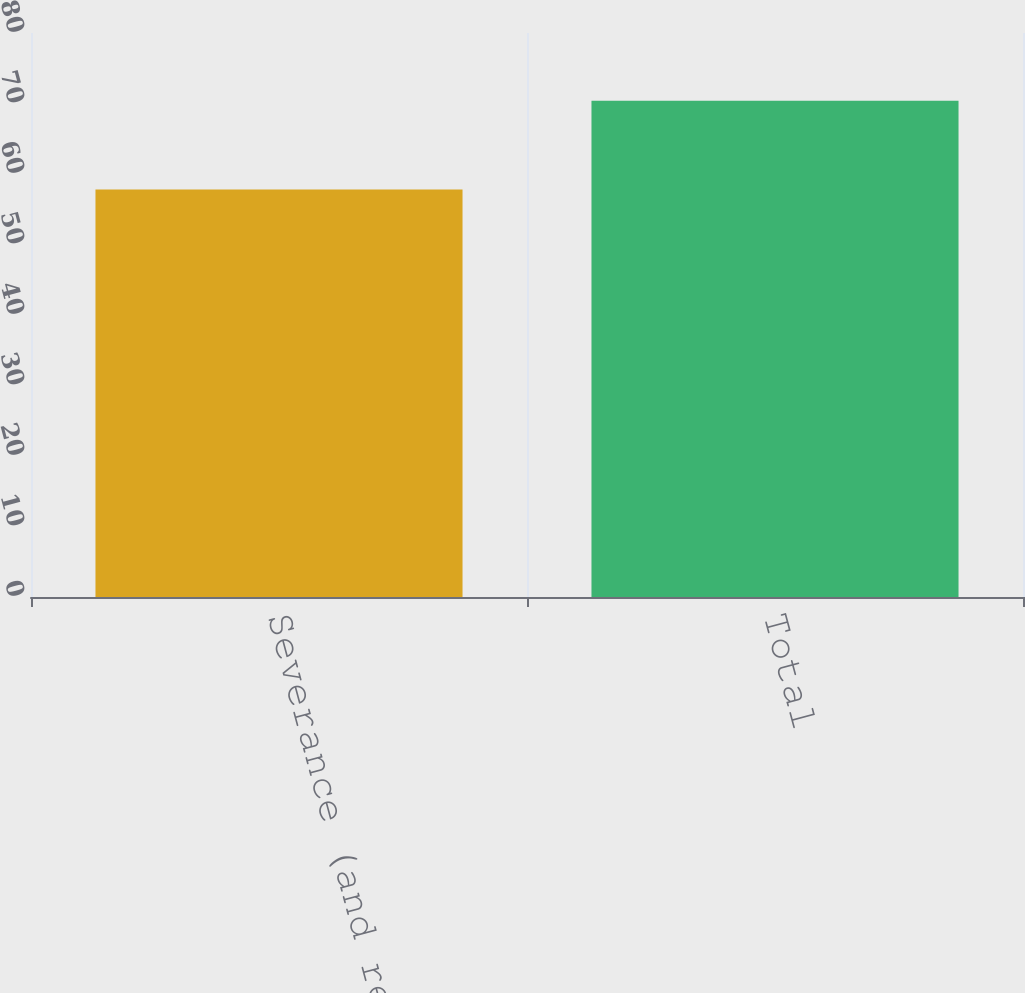Convert chart. <chart><loc_0><loc_0><loc_500><loc_500><bar_chart><fcel>Severance (and related costs)<fcel>Total<nl><fcel>57.8<fcel>70.4<nl></chart> 